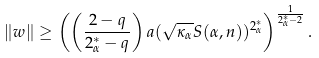Convert formula to latex. <formula><loc_0><loc_0><loc_500><loc_500>\| w \| \geq \left ( \left ( \frac { 2 - q } { { 2 ^ { * } _ { \alpha } } - q } \right ) { a ( \sqrt { \kappa _ { \alpha } } S ( \alpha , n ) ) ^ { 2 ^ { * } _ { \alpha } } } \right ) ^ { \frac { 1 } { { 2 ^ { * } _ { \alpha } } - 2 } } .</formula> 